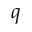<formula> <loc_0><loc_0><loc_500><loc_500>q</formula> 